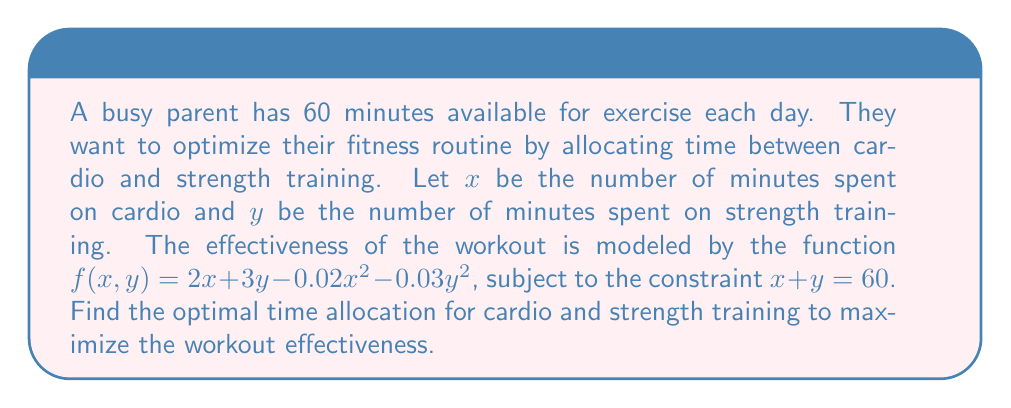Help me with this question. 1) We need to maximize $f(x,y) = 2x + 3y - 0.02x^2 - 0.03y^2$ subject to $x + y = 60$.

2) Use the constraint to eliminate $y$: $y = 60 - x$

3) Substitute this into the function:
   $f(x) = 2x + 3(60-x) - 0.02x^2 - 0.03(60-x)^2$
   $= 2x + 180 - 3x - 0.02x^2 - 0.03(3600 - 120x + x^2)$
   $= -x + 180 - 0.02x^2 - 108 + 3.6x - 0.03x^2$
   $= 72 + 2.6x - 0.05x^2$

4) To find the maximum, differentiate and set to zero:
   $\frac{df}{dx} = 2.6 - 0.1x = 0$

5) Solve for $x$:
   $0.1x = 2.6$
   $x = 26$

6) Calculate $y$:
   $y = 60 - x = 60 - 26 = 34$

7) Verify this is a maximum by checking the second derivative:
   $\frac{d^2f}{dx^2} = -0.1 < 0$, confirming a maximum.
Answer: 26 minutes cardio, 34 minutes strength training 